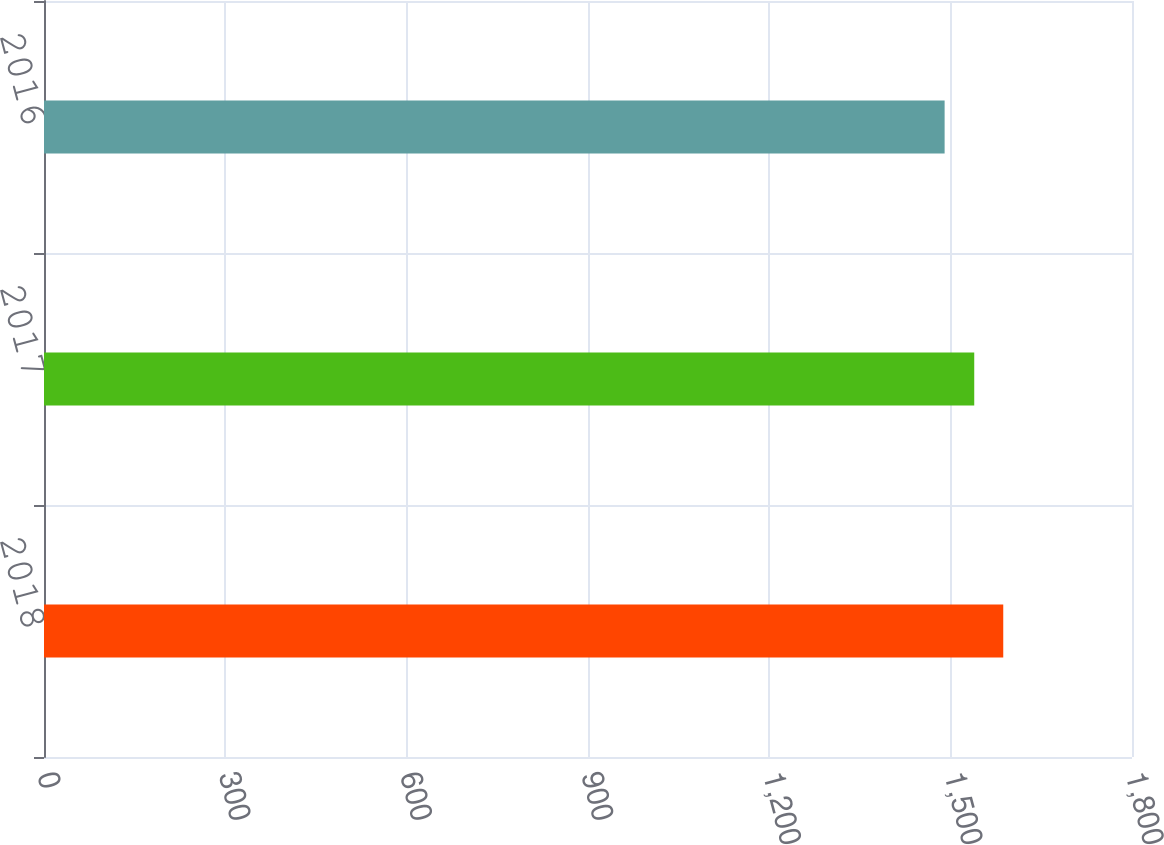Convert chart to OTSL. <chart><loc_0><loc_0><loc_500><loc_500><bar_chart><fcel>2018<fcel>2017<fcel>2016<nl><fcel>1587<fcel>1539<fcel>1490<nl></chart> 